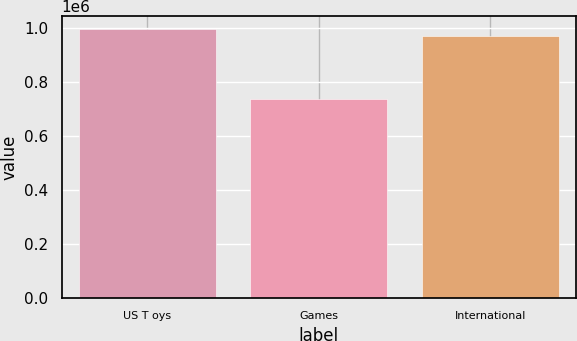<chart> <loc_0><loc_0><loc_500><loc_500><bar_chart><fcel>US T oys<fcel>Games<fcel>International<nl><fcel>996496<fcel>739782<fcel>970825<nl></chart> 